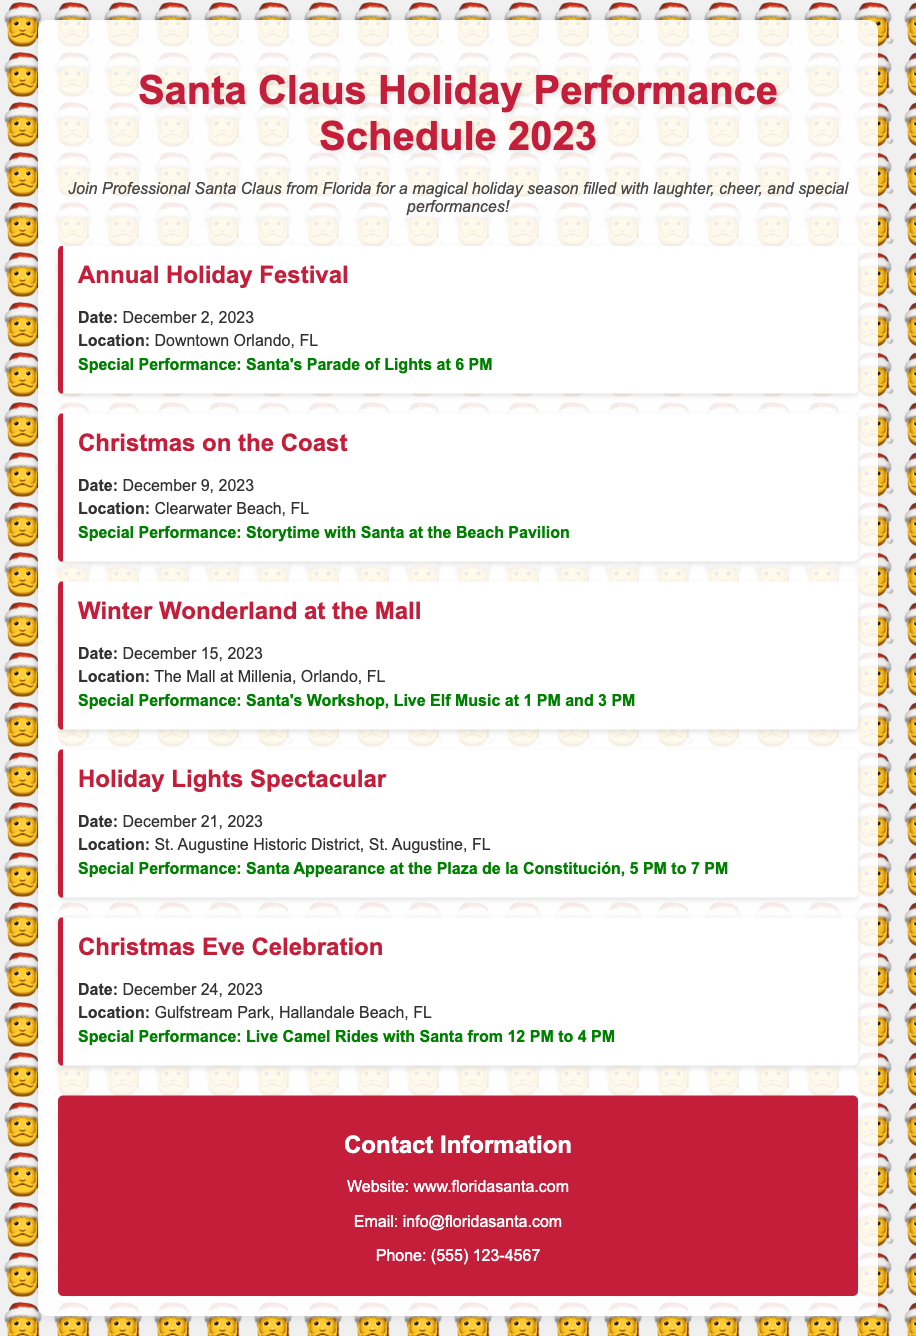what is the date of the Annual Holiday Festival? The date for the Annual Holiday Festival is specified in the document.
Answer: December 2, 2023 where is the Christmas on the Coast event held? The location for the Christmas on the Coast event is provided in the document.
Answer: Clearwater Beach, FL what special performance occurs on December 15, 2023? The document details the special performance happening on that date at the Winter Wonderland at the Mall.
Answer: Santa's Workshop, Live Elf Music at 1 PM and 3 PM how many live camel rides with Santa are available on Christmas Eve? The event details indicate the duration of the live camel rides with Santa.
Answer: from 12 PM to 4 PM which performance is highlighted at the Holiday Lights Spectacular? The document describes the special performance featured during this event.
Answer: Santa Appearance at the Plaza de la Constitución, 5 PM to 7 PM what type of event is scheduled for December 24, 2023? The type of event is indicated in the title of the performance schedule, specifically related to that date.
Answer: Christmas Eve Celebration 